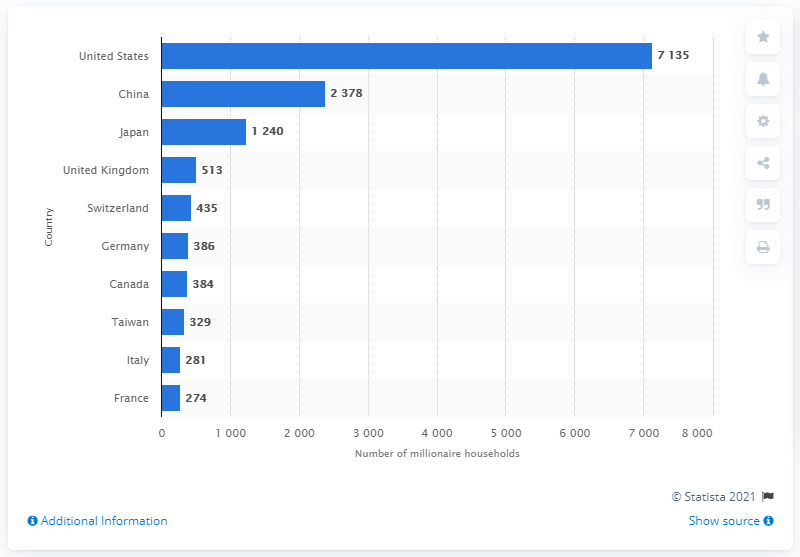List a handful of essential elements in this visual. In 2013, Canada had 384 millionaire households. 